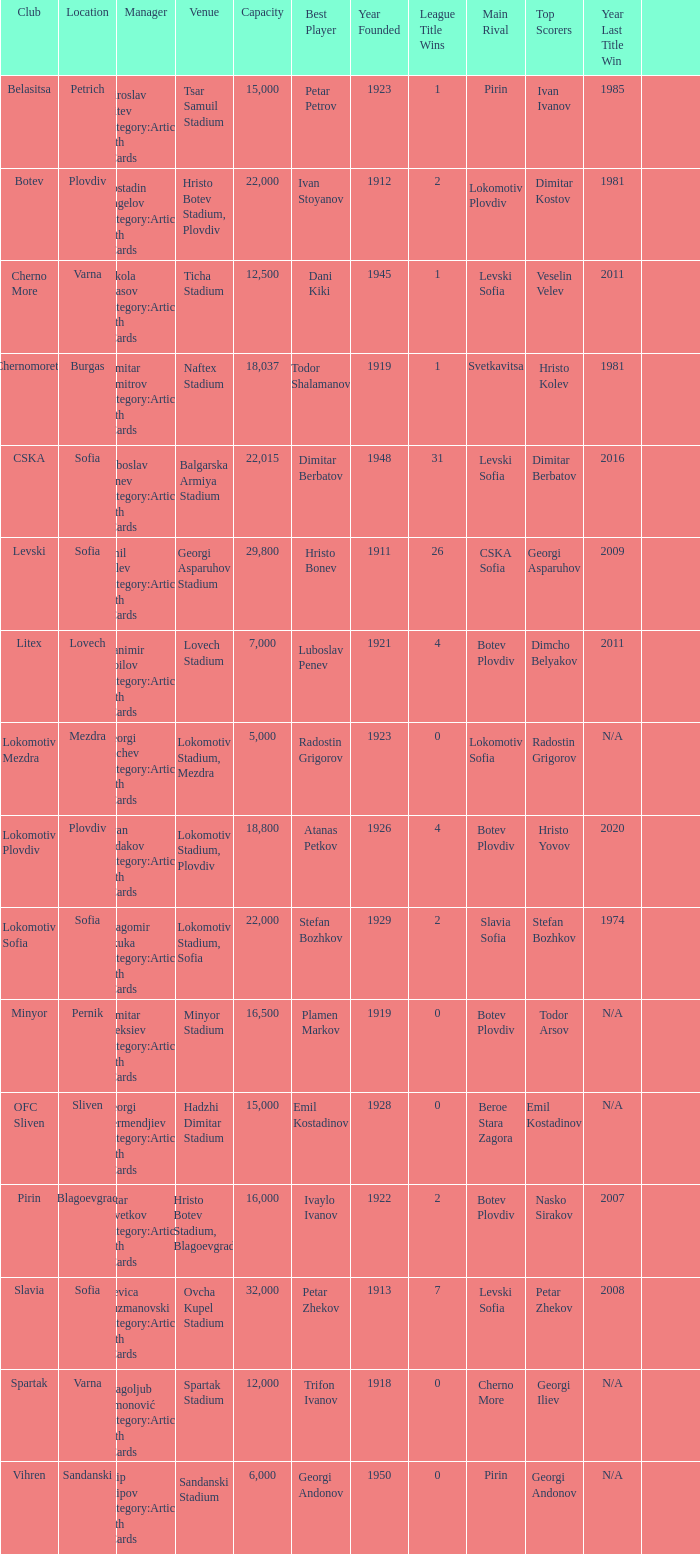What is the total number of capacity for the venue of the club, pirin? 1.0. 